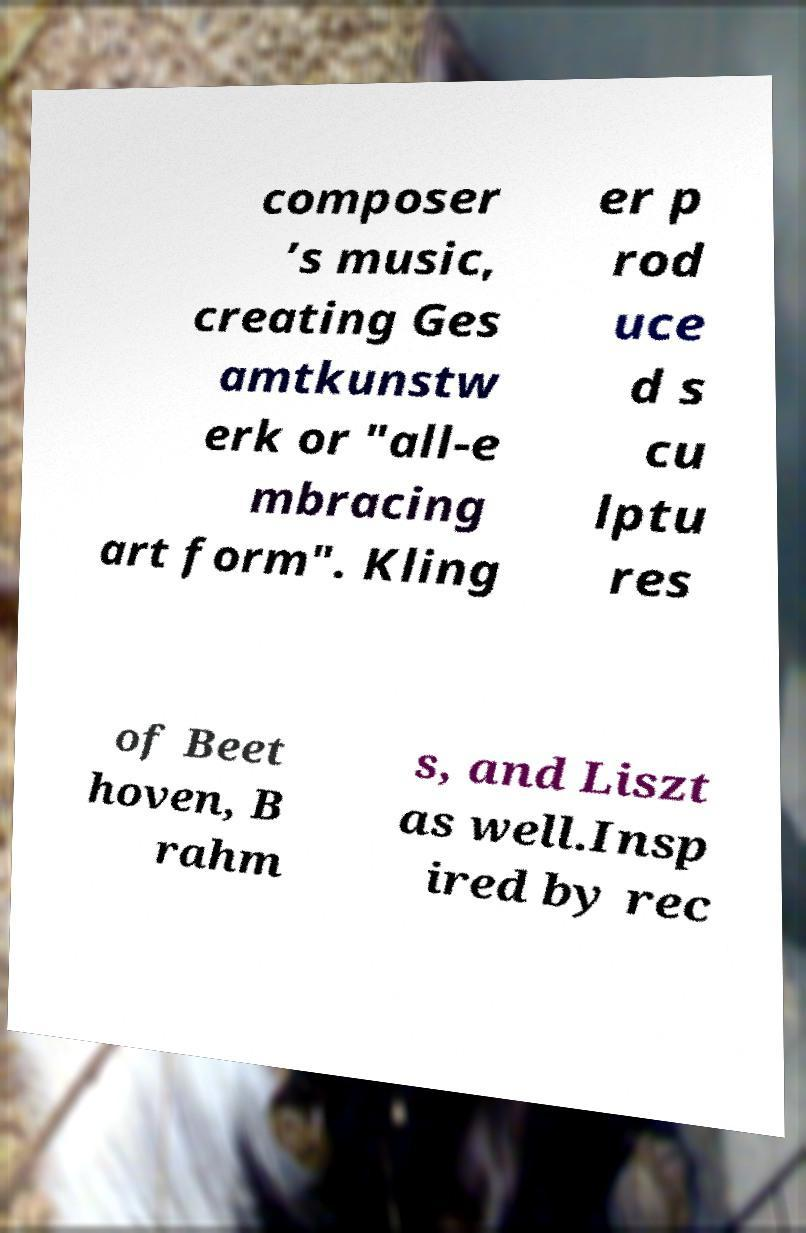Could you assist in decoding the text presented in this image and type it out clearly? composer ’s music, creating Ges amtkunstw erk or "all-e mbracing art form". Kling er p rod uce d s cu lptu res of Beet hoven, B rahm s, and Liszt as well.Insp ired by rec 